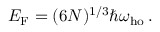<formula> <loc_0><loc_0><loc_500><loc_500>E _ { F } = ( 6 N ) ^ { 1 / 3 } \hbar { \omega } _ { h o } \, .</formula> 